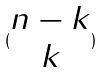Convert formula to latex. <formula><loc_0><loc_0><loc_500><loc_500>( \begin{matrix} n - k \\ k \end{matrix} )</formula> 